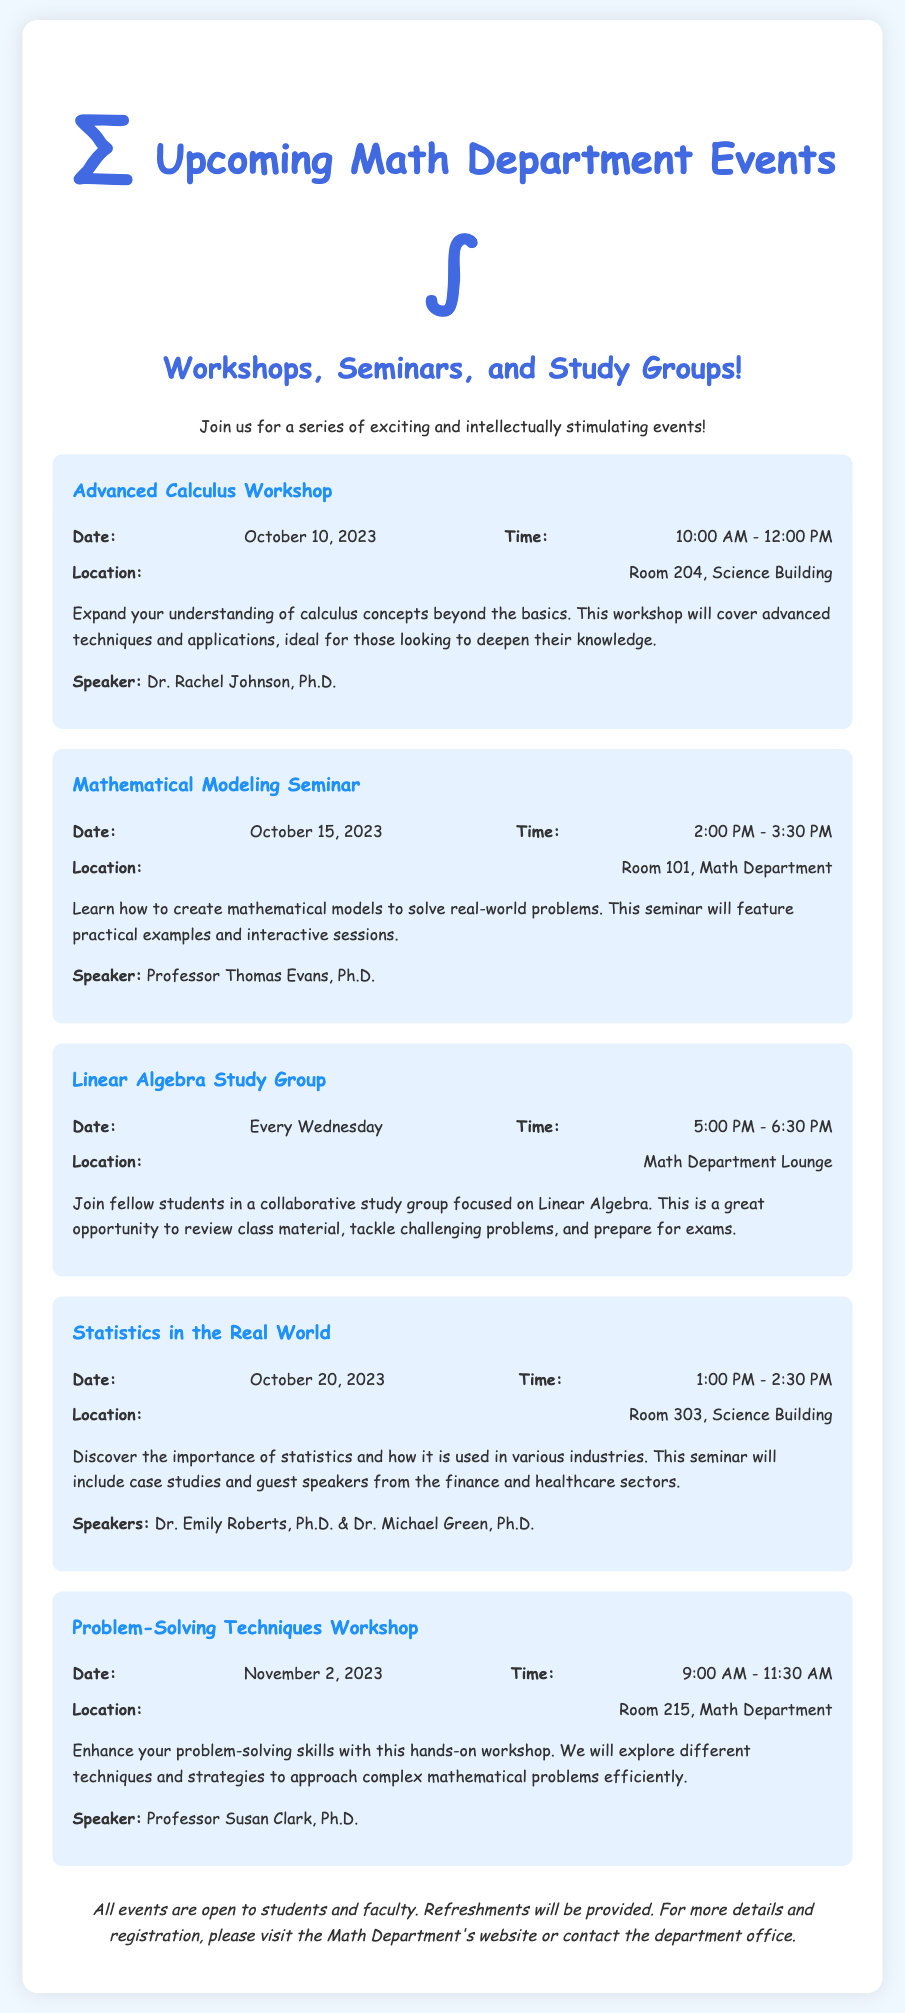What is the date of the Advanced Calculus Workshop? The date of the Advanced Calculus Workshop is specifically mentioned in the event details.
Answer: October 10, 2023 Who is the speaker for the Mathematical Modeling Seminar? The speaker's name is provided in the event description under the respective seminar.
Answer: Professor Thomas Evans, Ph.D What time does the Linear Algebra Study Group meet? The time is clearly indicated in the event details for the study group.
Answer: 5:00 PM - 6:30 PM Where is the Statistics in the Real World seminar held? The location is explicitly stated in the event details section of the seminar.
Answer: Room 303, Science Building How often does the Linear Algebra Study Group take place? The frequency is noted in the description of the study group event.
Answer: Every Wednesday What is the topic of the workshop on November 2, 2023? The event title specifies the workshop's main focus.
Answer: Problem-Solving Techniques Who are the speakers for the Statistics in the Real World seminar? The names of the speakers are mentioned at the end of the event description for the seminar.
Answer: Dr. Emily Roberts, Ph.D. & Dr. Michael Green, Ph.D What is the purpose of the Advanced Calculus Workshop? The purpose is detailed in the description, indicating what participants can expect to learn.
Answer: Expand understanding of calculus concepts beyond the basics 